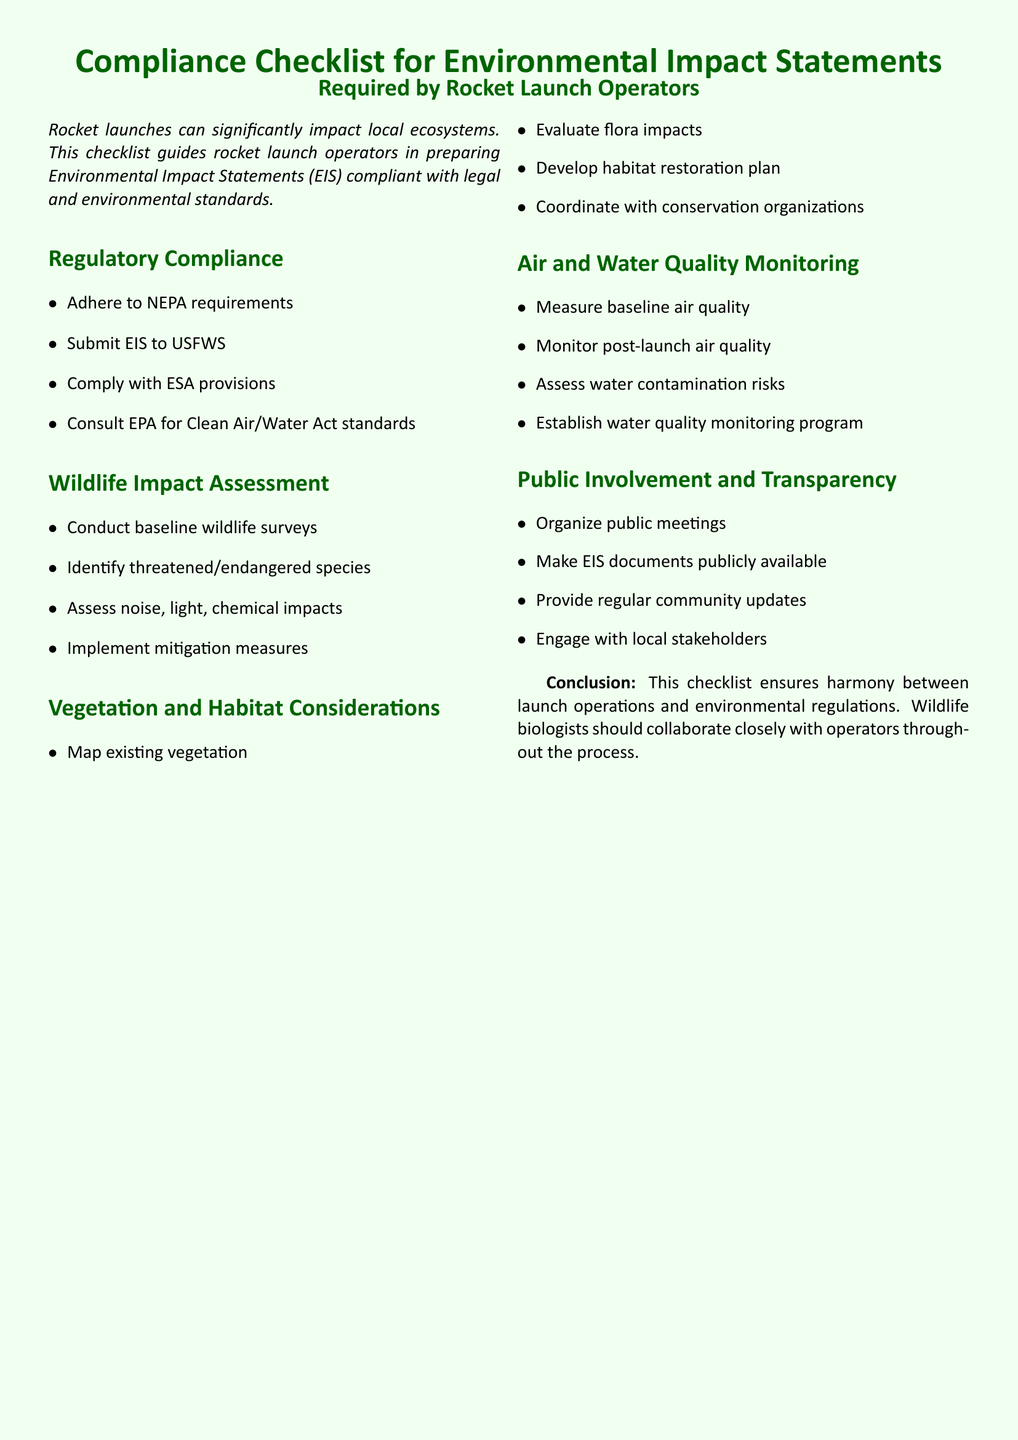What are the NEPA requirements? NEPA requirements are obligations that must be adhered to in environmental assessments.
Answer: Adhere to NEPA requirements Who must the EIS be submitted to? The EIS must be submitted to the US Fish and Wildlife Service for review.
Answer: USFWS What does ESA stand for? ESA provisions refer to those outlined in the Endangered Species Act.
Answer: ESA What is a necessary step in wildlife impact assessment? A necessary step is to conduct baseline wildlife surveys to understand existing conditions.
Answer: Conduct baseline wildlife surveys What is a key component of vegetation and habitat considerations? Mapping existing vegetation is vital for understanding ecological contexts.
Answer: Map existing vegetation How should air quality be monitored? Baseline air quality should be measured before launches for effective comparison.
Answer: Measure baseline air quality What is an essential aspect of public involvement? Organizing public meetings is crucial for community engagement and information sharing.
Answer: Organize public meetings What is the purpose of a habitat restoration plan? The plan aims to restore and maintain ecological balance after disturbances.
Answer: Develop habitat restoration plan What role do conservation organizations play? They coordinate with launch operators to ensure environmentally sound practices.
Answer: Coordinate with conservation organizations 